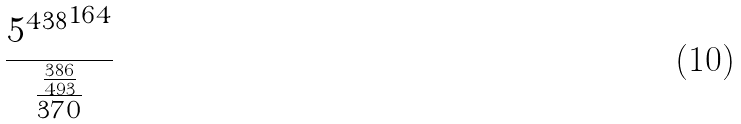Convert formula to latex. <formula><loc_0><loc_0><loc_500><loc_500>\frac { { 5 ^ { 4 3 8 } } ^ { 1 6 4 } } { \frac { \frac { 3 8 6 } { 4 9 3 } } { 3 7 0 } }</formula> 